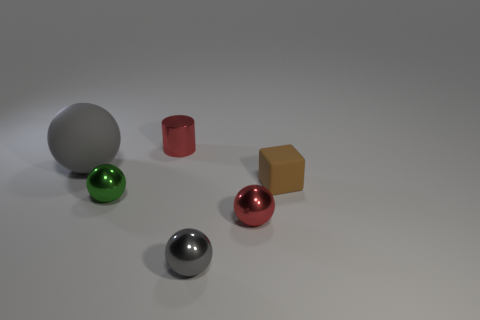How many things are small gray spheres or metal objects?
Your response must be concise. 4. What number of small metallic balls are to the right of the small gray sphere and left of the tiny red cylinder?
Your response must be concise. 0. Is the number of red objects to the left of the tiny red sphere less than the number of small gray metal balls?
Make the answer very short. No. What shape is the brown rubber thing that is the same size as the red metallic cylinder?
Keep it short and to the point. Cube. How many other things are there of the same color as the metal cylinder?
Provide a short and direct response. 1. Does the brown object have the same size as the matte ball?
Offer a terse response. No. How many objects are big gray metal cylinders or balls right of the big sphere?
Provide a succinct answer. 3. Is the number of brown objects that are on the left side of the red shiny sphere less than the number of red spheres that are to the left of the green sphere?
Your answer should be compact. No. How many other objects are there of the same material as the tiny brown thing?
Your response must be concise. 1. There is a tiny ball on the right side of the tiny gray metal ball; does it have the same color as the small rubber block?
Offer a very short reply. No. 